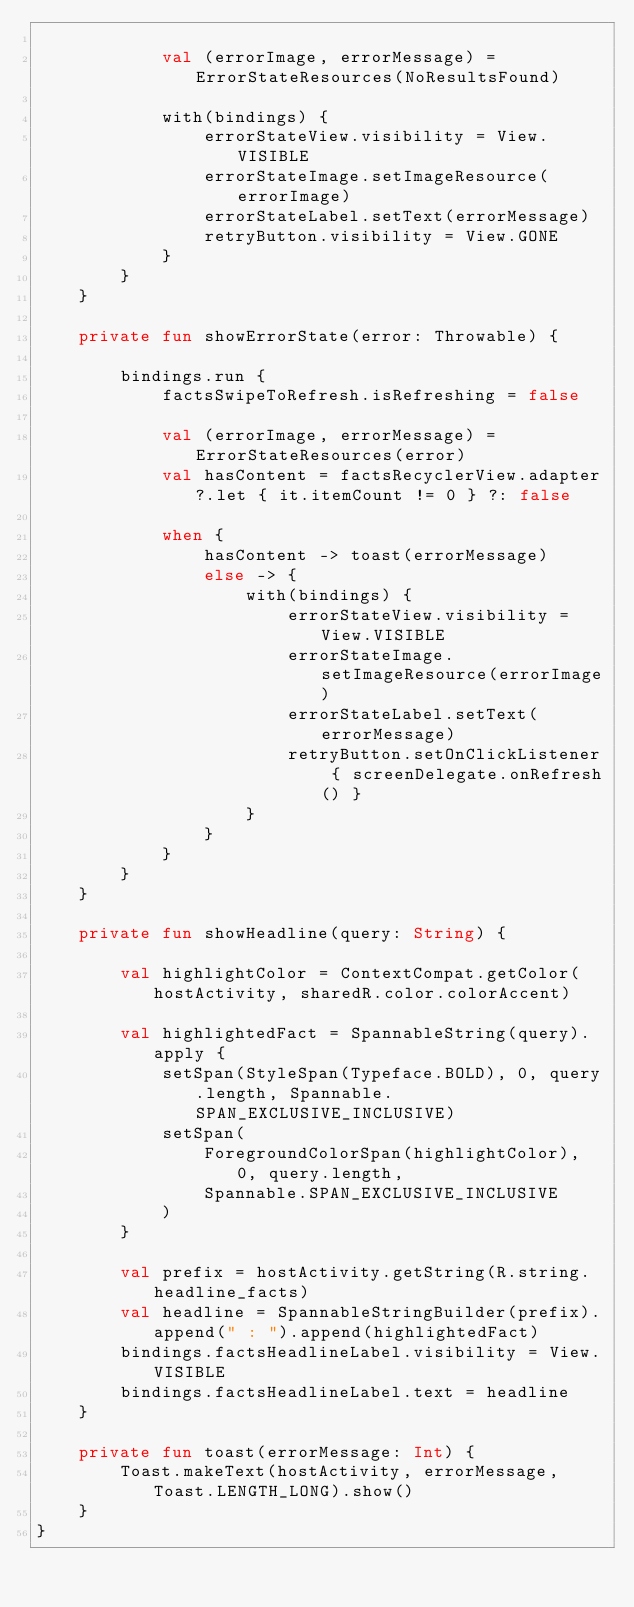<code> <loc_0><loc_0><loc_500><loc_500><_Kotlin_>
            val (errorImage, errorMessage) = ErrorStateResources(NoResultsFound)

            with(bindings) {
                errorStateView.visibility = View.VISIBLE
                errorStateImage.setImageResource(errorImage)
                errorStateLabel.setText(errorMessage)
                retryButton.visibility = View.GONE
            }
        }
    }

    private fun showErrorState(error: Throwable) {

        bindings.run {
            factsSwipeToRefresh.isRefreshing = false

            val (errorImage, errorMessage) = ErrorStateResources(error)
            val hasContent = factsRecyclerView.adapter?.let { it.itemCount != 0 } ?: false

            when {
                hasContent -> toast(errorMessage)
                else -> {
                    with(bindings) {
                        errorStateView.visibility = View.VISIBLE
                        errorStateImage.setImageResource(errorImage)
                        errorStateLabel.setText(errorMessage)
                        retryButton.setOnClickListener { screenDelegate.onRefresh() }
                    }
                }
            }
        }
    }

    private fun showHeadline(query: String) {

        val highlightColor = ContextCompat.getColor(hostActivity, sharedR.color.colorAccent)

        val highlightedFact = SpannableString(query).apply {
            setSpan(StyleSpan(Typeface.BOLD), 0, query.length, Spannable.SPAN_EXCLUSIVE_INCLUSIVE)
            setSpan(
                ForegroundColorSpan(highlightColor), 0, query.length,
                Spannable.SPAN_EXCLUSIVE_INCLUSIVE
            )
        }

        val prefix = hostActivity.getString(R.string.headline_facts)
        val headline = SpannableStringBuilder(prefix).append(" : ").append(highlightedFact)
        bindings.factsHeadlineLabel.visibility = View.VISIBLE
        bindings.factsHeadlineLabel.text = headline
    }

    private fun toast(errorMessage: Int) {
        Toast.makeText(hostActivity, errorMessage, Toast.LENGTH_LONG).show()
    }
}
</code> 